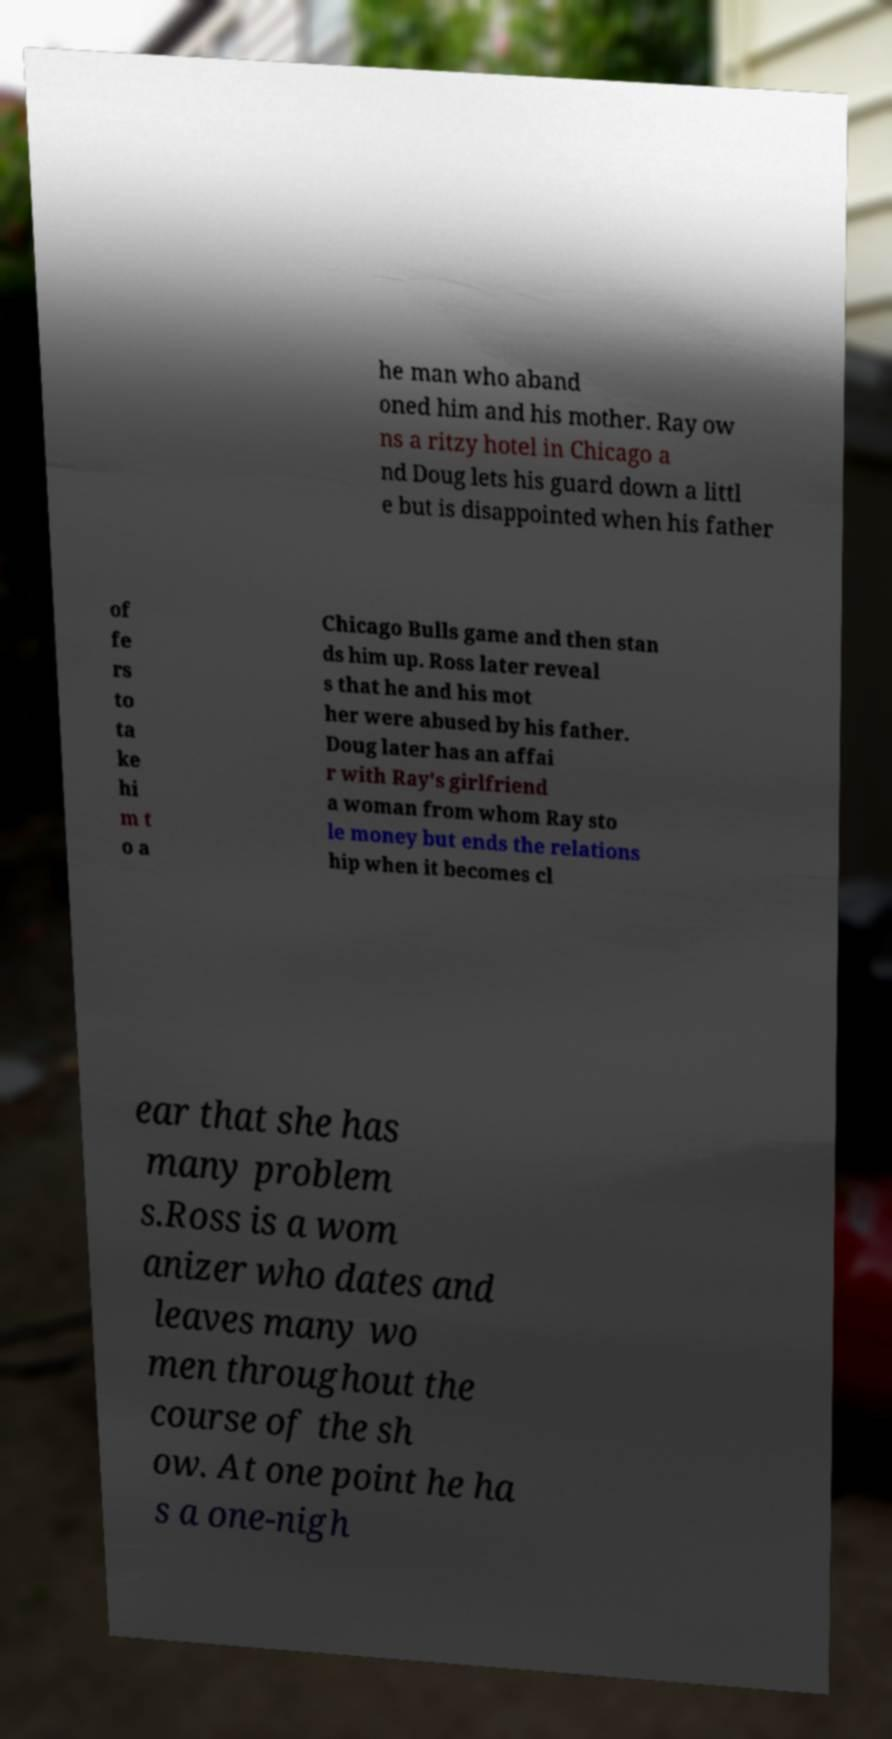For documentation purposes, I need the text within this image transcribed. Could you provide that? he man who aband oned him and his mother. Ray ow ns a ritzy hotel in Chicago a nd Doug lets his guard down a littl e but is disappointed when his father of fe rs to ta ke hi m t o a Chicago Bulls game and then stan ds him up. Ross later reveal s that he and his mot her were abused by his father. Doug later has an affai r with Ray's girlfriend a woman from whom Ray sto le money but ends the relations hip when it becomes cl ear that she has many problem s.Ross is a wom anizer who dates and leaves many wo men throughout the course of the sh ow. At one point he ha s a one-nigh 